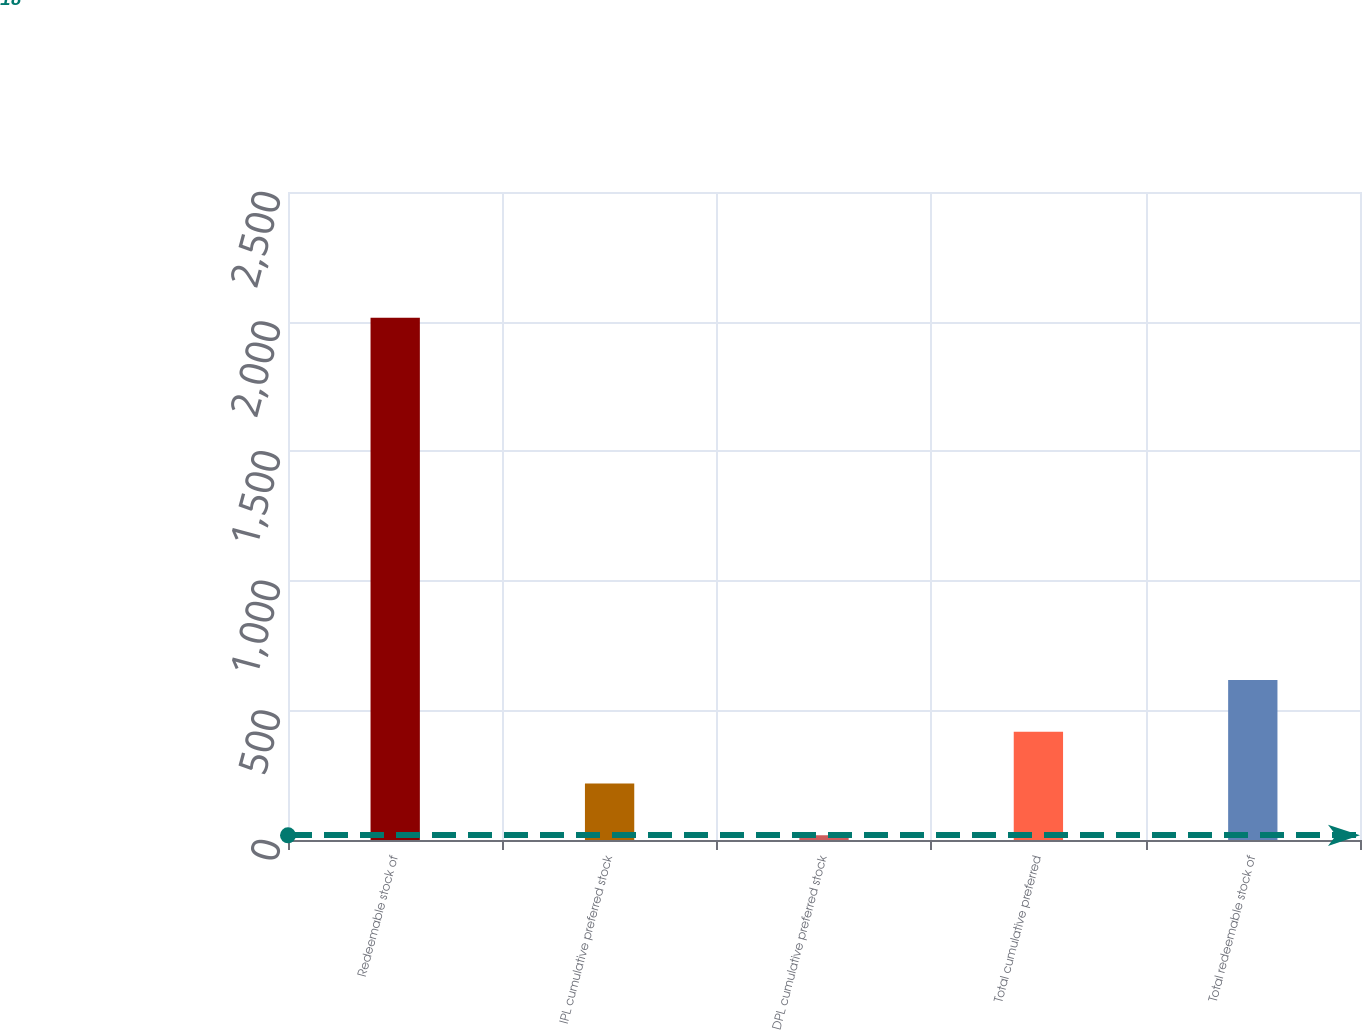Convert chart. <chart><loc_0><loc_0><loc_500><loc_500><bar_chart><fcel>Redeemable stock of<fcel>IPL cumulative preferred stock<fcel>DPL cumulative preferred stock<fcel>Total cumulative preferred<fcel>Total redeemable stock of<nl><fcel>2015<fcel>217.7<fcel>18<fcel>417.4<fcel>617.1<nl></chart> 